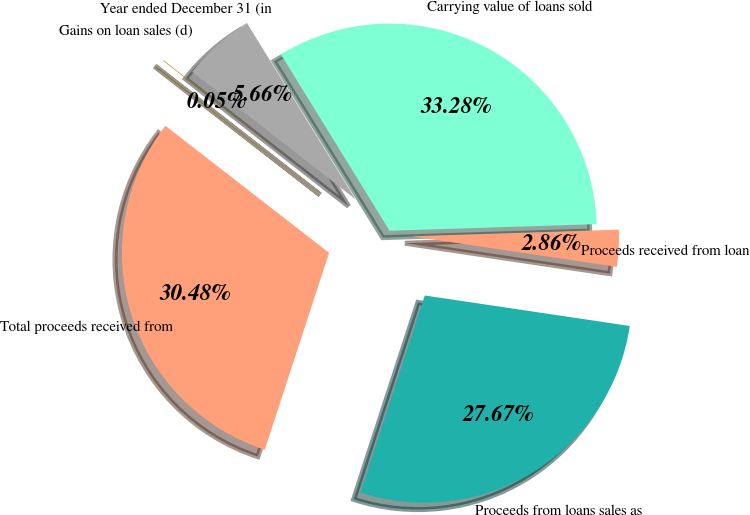Convert chart to OTSL. <chart><loc_0><loc_0><loc_500><loc_500><pie_chart><fcel>Year ended December 31 (in<fcel>Carrying value of loans sold<fcel>Proceeds received from loan<fcel>Proceeds from loans sales as<fcel>Total proceeds received from<fcel>Gains on loan sales (d)<nl><fcel>5.66%<fcel>33.28%<fcel>2.86%<fcel>27.67%<fcel>30.48%<fcel>0.05%<nl></chart> 